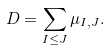<formula> <loc_0><loc_0><loc_500><loc_500>D = \sum _ { I \leq J } \mu _ { I , J } .</formula> 